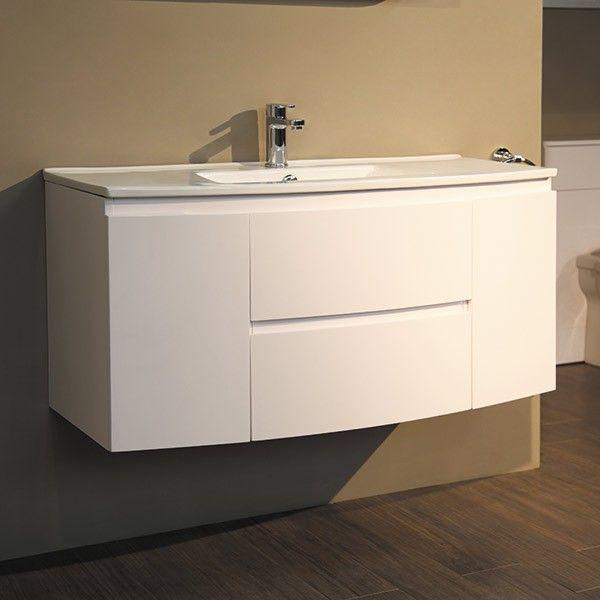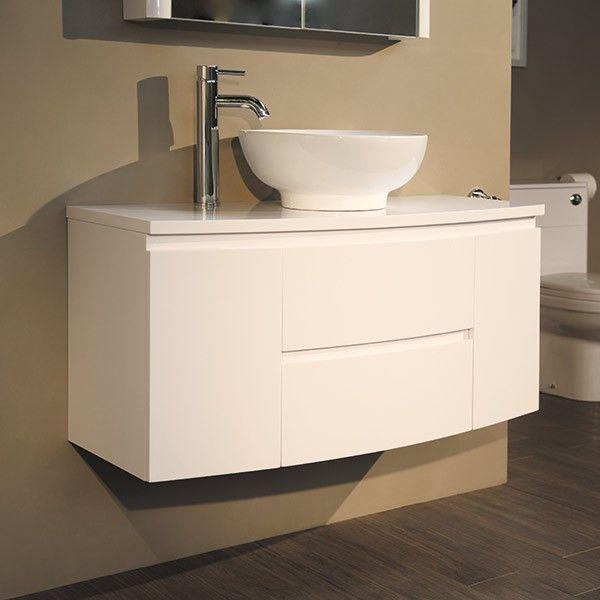The first image is the image on the left, the second image is the image on the right. Given the left and right images, does the statement "IN at least one image there is a single raised basin on top of a floating cabinet shelf." hold true? Answer yes or no. Yes. The first image is the image on the left, the second image is the image on the right. Analyze the images presented: Is the assertion "One of the sinks is a bowl type." valid? Answer yes or no. Yes. 